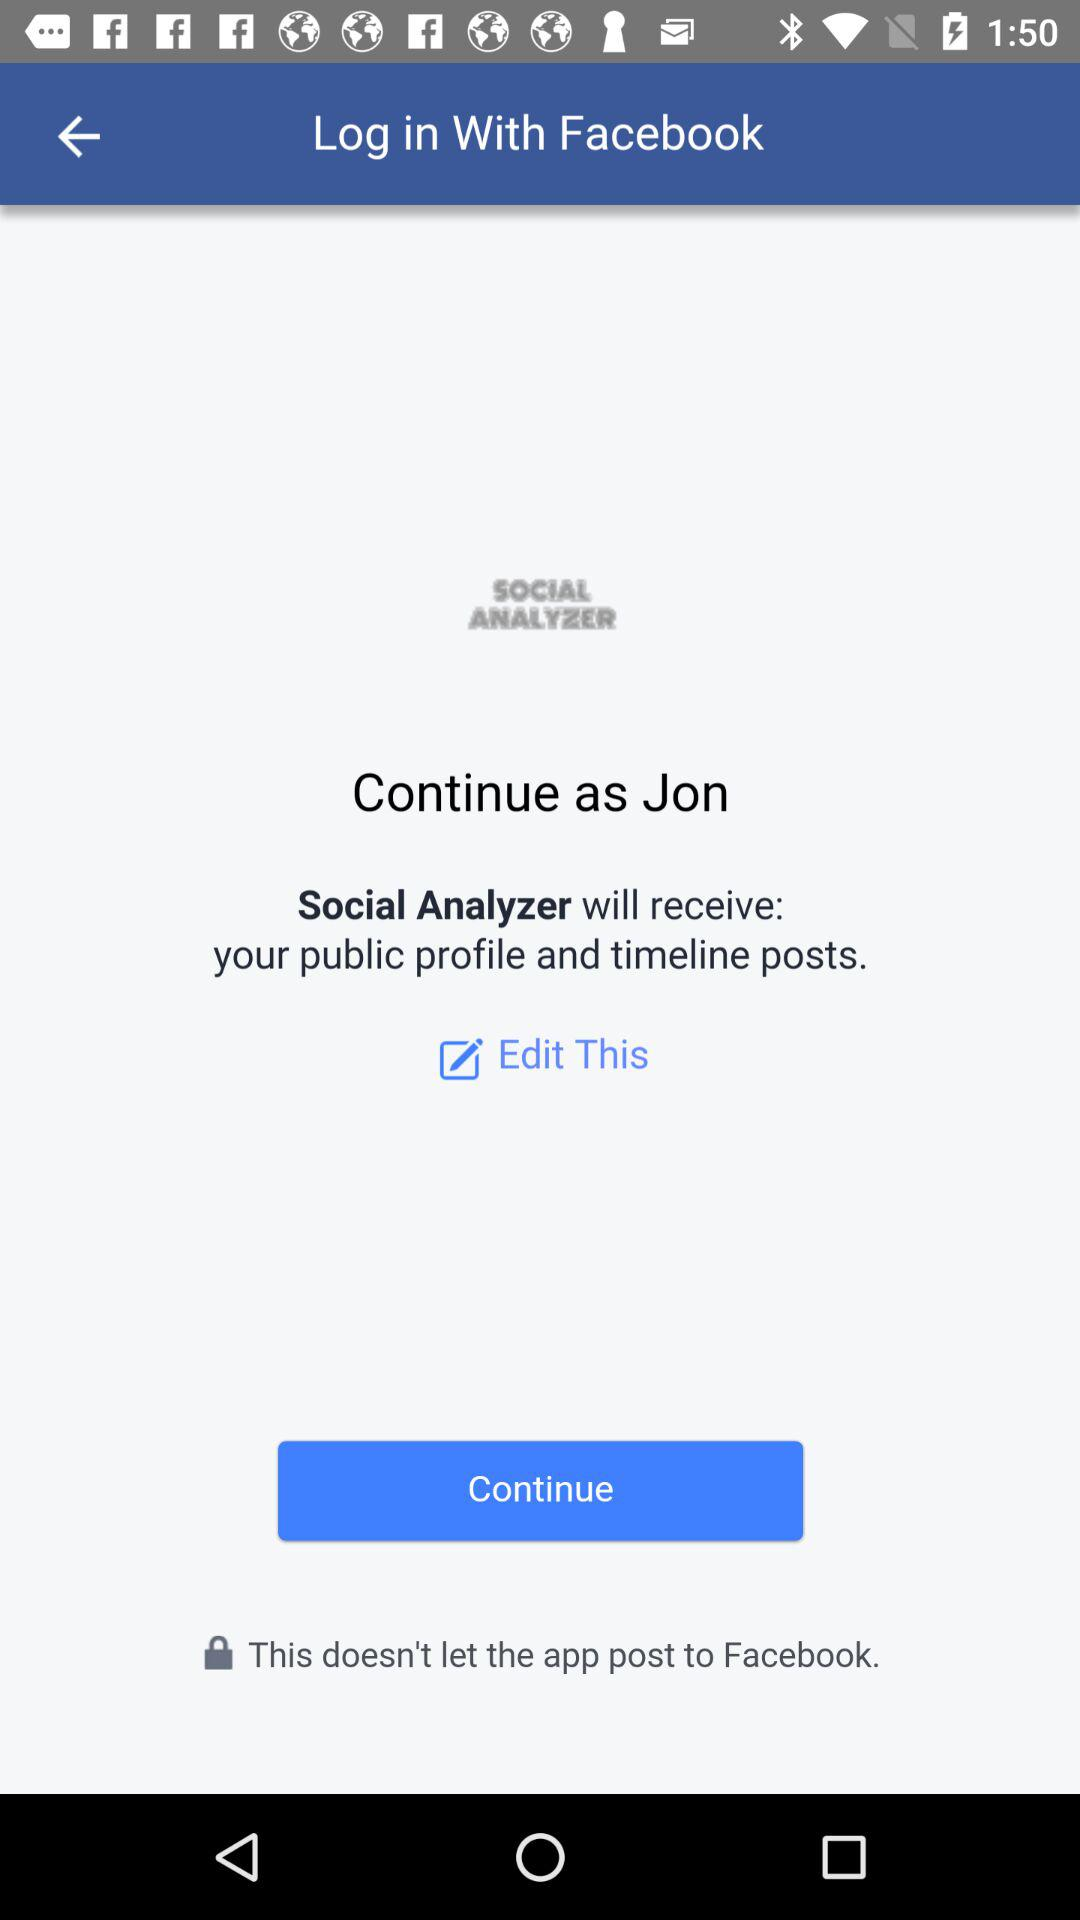What is the user name? The user name is Jon. 